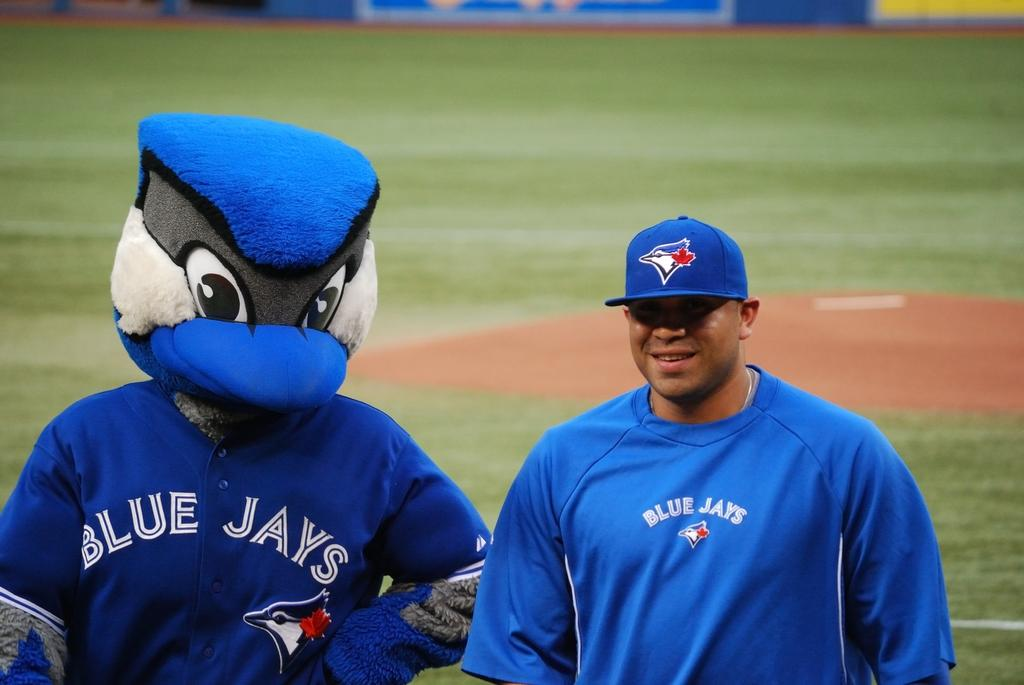<image>
Give a short and clear explanation of the subsequent image. a blue jays jersey on a player walking 